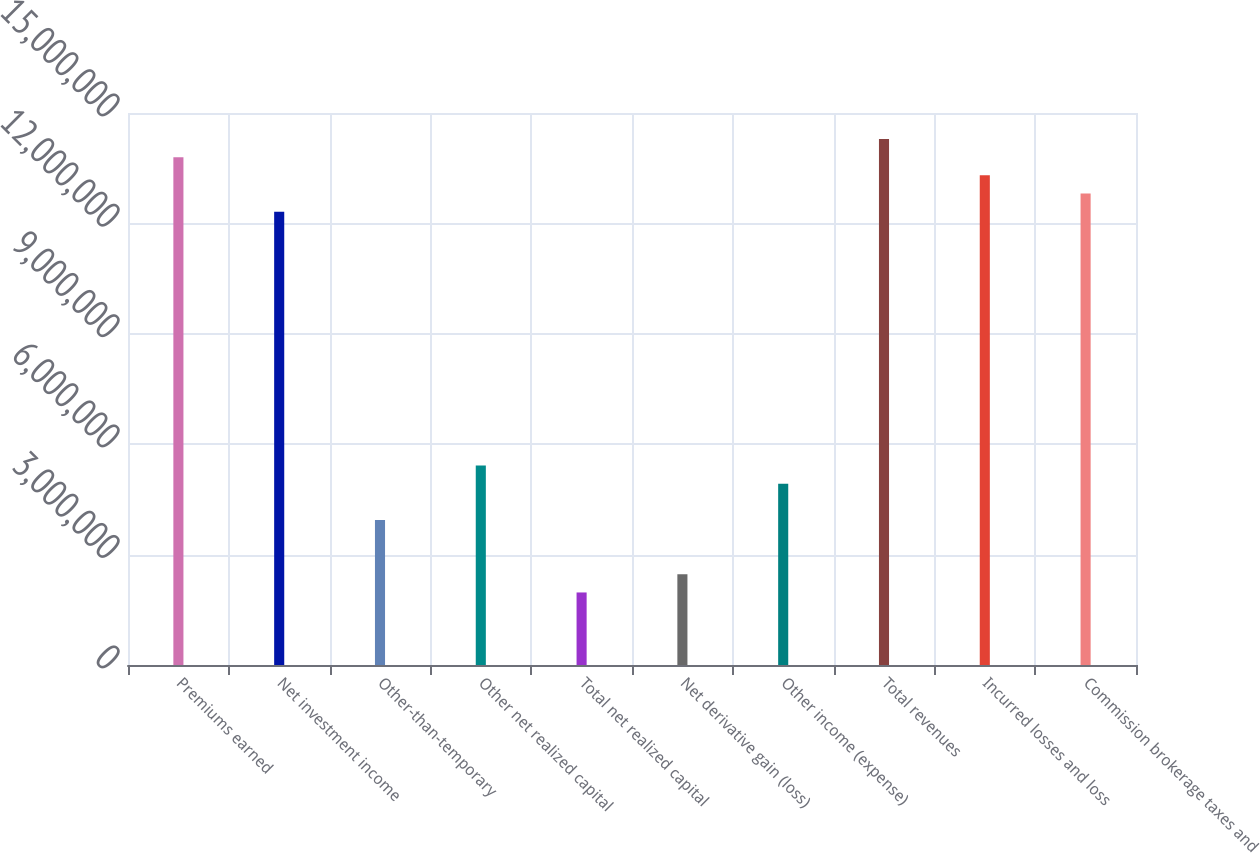<chart> <loc_0><loc_0><loc_500><loc_500><bar_chart><fcel>Premiums earned<fcel>Net investment income<fcel>Other-than-temporary<fcel>Other net realized capital<fcel>Total net realized capital<fcel>Net derivative gain (loss)<fcel>Other income (expense)<fcel>Total revenues<fcel>Incurred losses and loss<fcel>Commission brokerage taxes and<nl><fcel>1.37981e+07<fcel>1.23198e+07<fcel>3.94233e+06<fcel>5.4207e+06<fcel>1.97116e+06<fcel>2.46395e+06<fcel>4.92791e+06<fcel>1.42909e+07<fcel>1.33053e+07<fcel>1.28126e+07<nl></chart> 